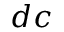<formula> <loc_0><loc_0><loc_500><loc_500>d c</formula> 